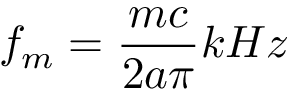Convert formula to latex. <formula><loc_0><loc_0><loc_500><loc_500>f _ { m } = { \frac { m c } { 2 a \pi } } k H z</formula> 